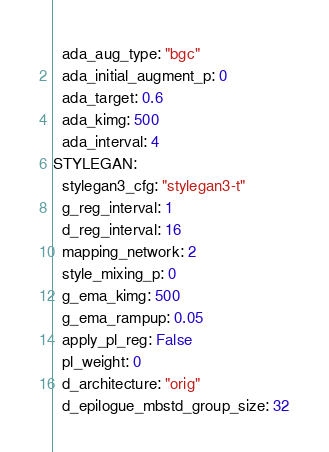<code> <loc_0><loc_0><loc_500><loc_500><_YAML_>  ada_aug_type: "bgc"
  ada_initial_augment_p: 0
  ada_target: 0.6
  ada_kimg: 500
  ada_interval: 4
STYLEGAN:
  stylegan3_cfg: "stylegan3-t"
  g_reg_interval: 1
  d_reg_interval: 16
  mapping_network: 2
  style_mixing_p: 0
  g_ema_kimg: 500
  g_ema_rampup: 0.05
  apply_pl_reg: False
  pl_weight: 0
  d_architecture: "orig"
  d_epilogue_mbstd_group_size: 32
</code> 